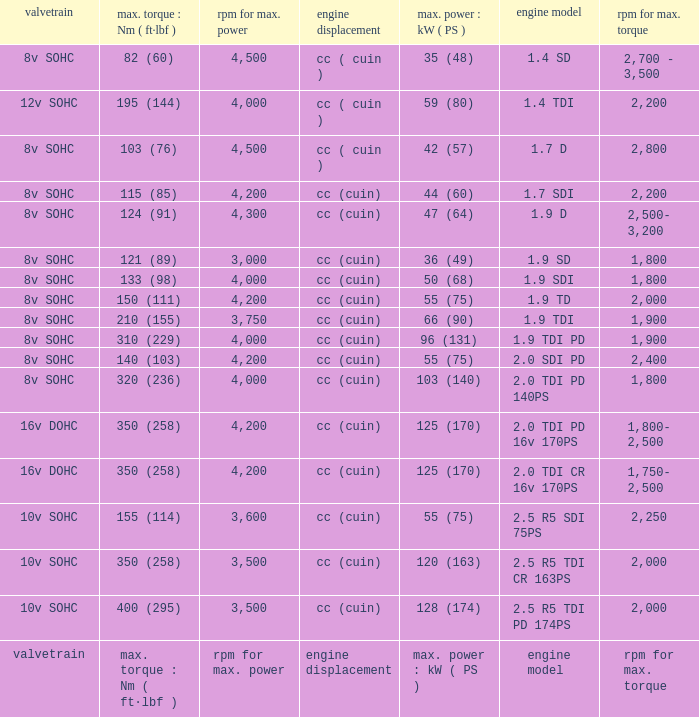What is the valvetrain with an engine model that is engine model? Valvetrain. 